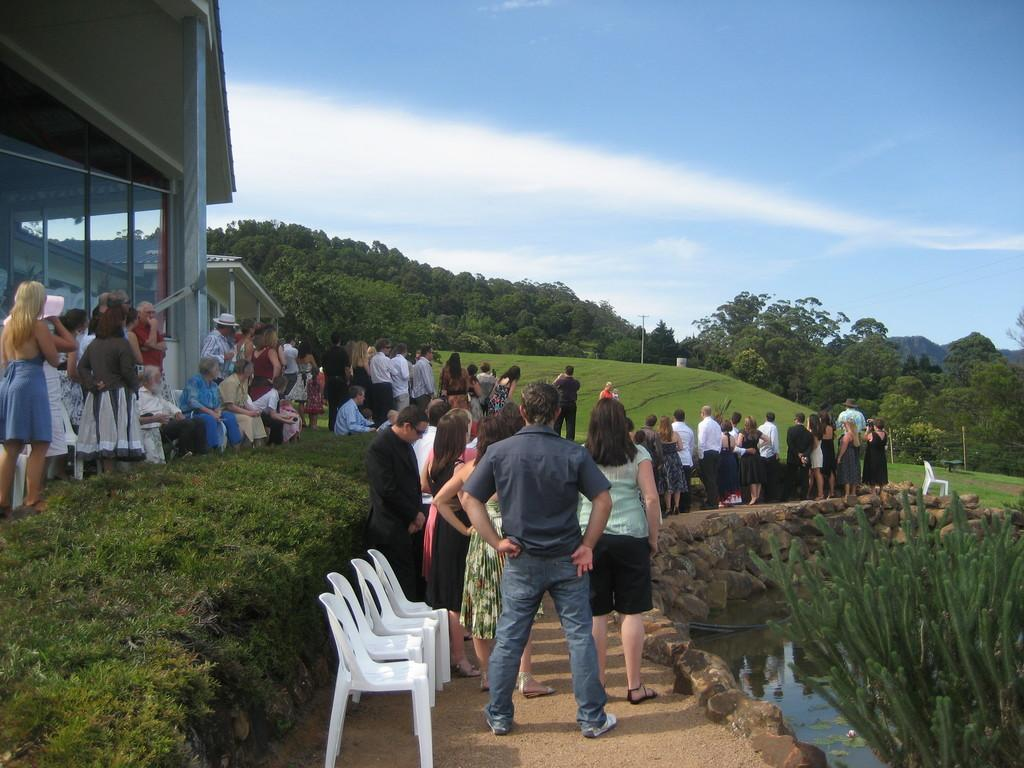What type of furniture is present in the image? There are chairs in the image. What can be seen on the left side of the image? There are plants and a building on the left side of the image. How many people are present in the image? There are many people standing in the image. What is visible in the background of the image? The sky is visible in the image. What type of twig is being held by the father in the image? There is no father or twig present in the image. What type of flesh can be seen on the people in the image? There is no flesh visible on the people in the image; they are fully clothed. 